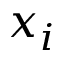Convert formula to latex. <formula><loc_0><loc_0><loc_500><loc_500>x _ { i }</formula> 